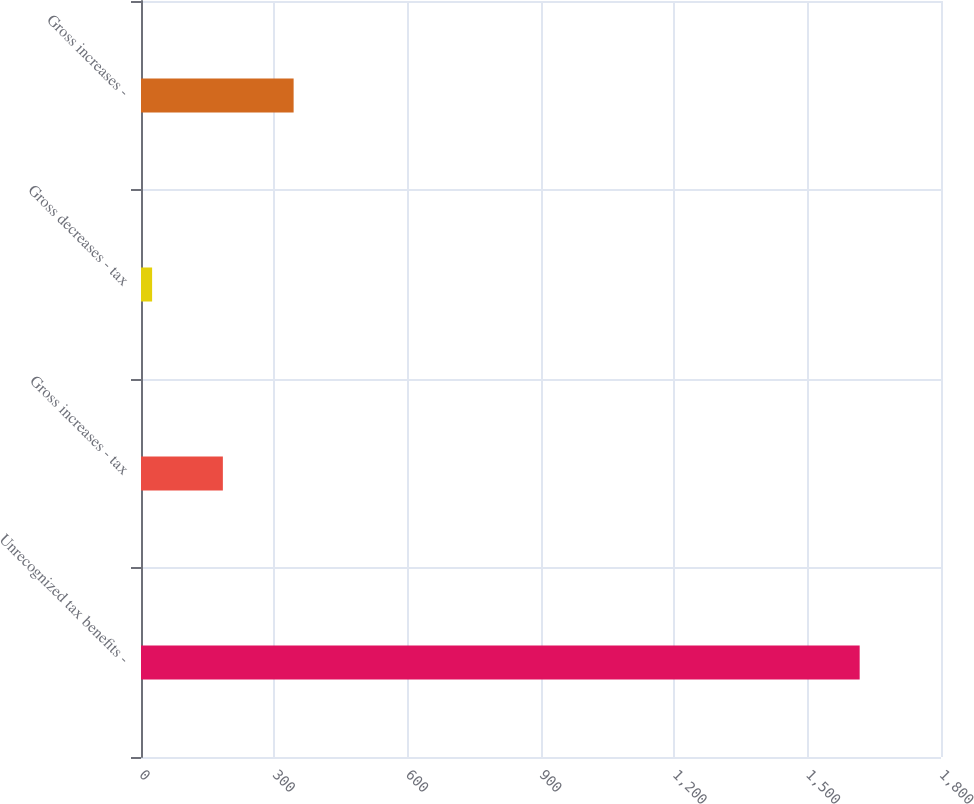<chart> <loc_0><loc_0><loc_500><loc_500><bar_chart><fcel>Unrecognized tax benefits -<fcel>Gross increases - tax<fcel>Gross decreases - tax<fcel>Gross increases -<nl><fcel>1617<fcel>184.2<fcel>25<fcel>343.4<nl></chart> 